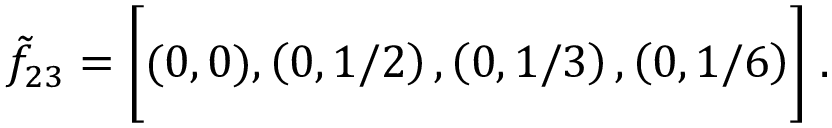<formula> <loc_0><loc_0><loc_500><loc_500>\tilde { f } _ { 2 3 } = \left [ ( 0 , 0 ) , \left ( 0 , 1 / 2 \right ) , \left ( 0 , 1 / 3 \right ) , \left ( 0 , 1 / 6 \right ) \right ] \, .</formula> 